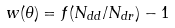Convert formula to latex. <formula><loc_0><loc_0><loc_500><loc_500>w ( \theta ) = f ( N _ { d d } / N _ { d r } ) - 1</formula> 